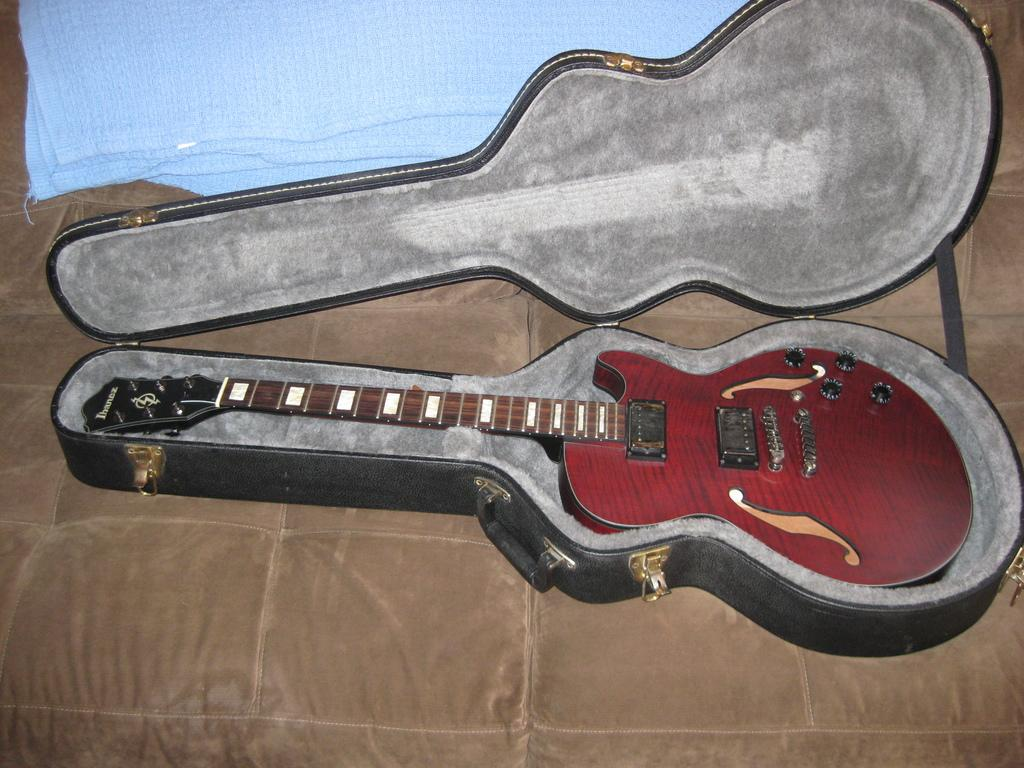What is the main object in the center of the image? There is a brown color object in the center of the image. What is placed on top of the brown object? There is a guitar box on the brown object. Is there any covering on the guitar box? Yes, there is a cloth on the guitar box. What is inside the guitar box? There is a guitar inside the guitar box. Can you see a tiger playing with the paint in the basin in the image? No, there is no tiger, paint, or basin present in the image. 